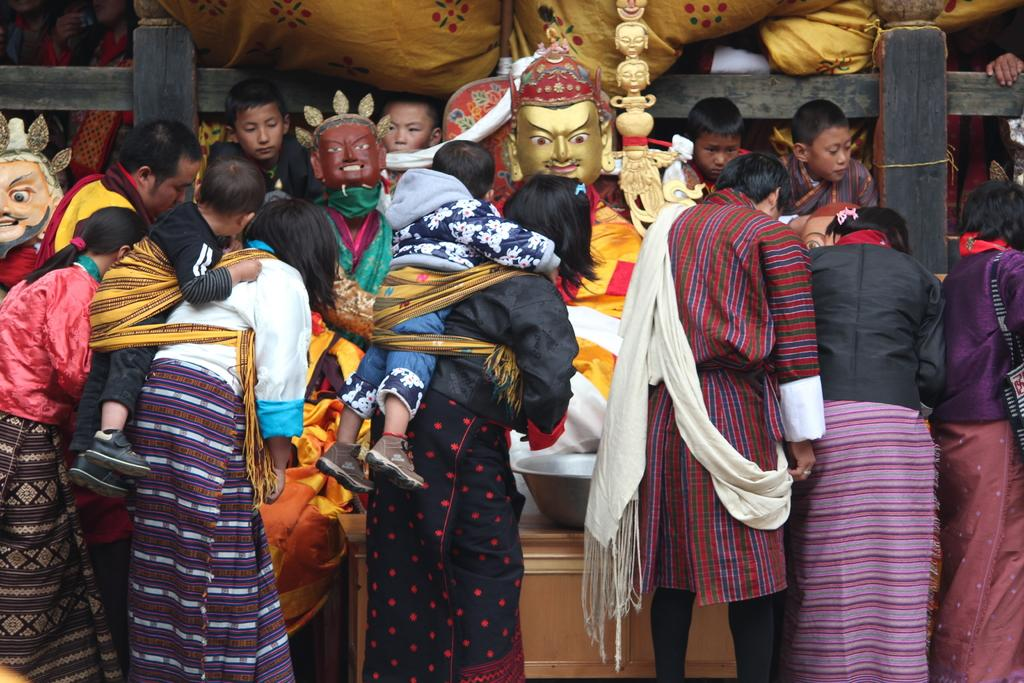How many people are in the image? There is a group of people in the image, but the exact number is not specified. What is in the bowl that is visible in the image? There is a bowl in the image, but its contents are not mentioned. What type of objects are the statues in the image? The statues in the image are not described in detail. What type of clothes are visible in the image? There are clothes in the image, but their style or color is not specified. Can you describe the unspecified objects in the image? The unspecified objects in the image are not described in detail. How many trains can be seen in the image? There are no trains present in the image. Can you describe the request made by the person in the image? There is no person making a request in the image. 